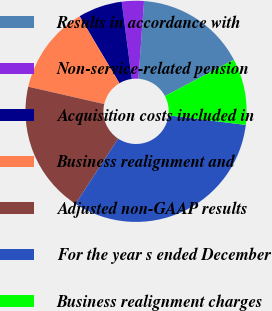Convert chart. <chart><loc_0><loc_0><loc_500><loc_500><pie_chart><fcel>Results in accordance with<fcel>Non-service-related pension<fcel>Acquisition costs included in<fcel>Business realignment and<fcel>Adjusted non-GAAP results<fcel>For the year s ended December<fcel>Business realignment charges<nl><fcel>16.13%<fcel>3.23%<fcel>6.45%<fcel>12.9%<fcel>19.35%<fcel>32.26%<fcel>9.68%<nl></chart> 